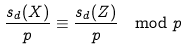Convert formula to latex. <formula><loc_0><loc_0><loc_500><loc_500>\frac { s _ { d } ( X ) } p \equiv \frac { s _ { d } ( Z ) } p \mod p</formula> 